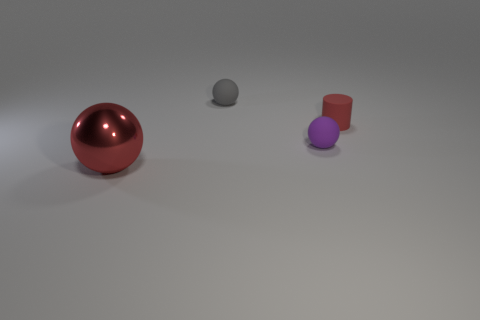There is a large metal ball; is its color the same as the tiny sphere behind the small purple matte thing? No, the colors are different. The large metal ball has a reflective red surface, while the smaller sphere has a non-reflective, neutral gray color. 